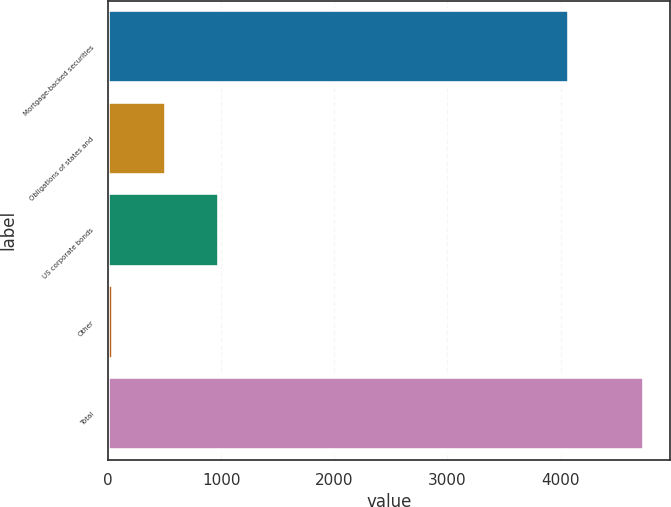Convert chart to OTSL. <chart><loc_0><loc_0><loc_500><loc_500><bar_chart><fcel>Mortgage-backed securities<fcel>Obligations of states and<fcel>US corporate bonds<fcel>Other<fcel>Total<nl><fcel>4071<fcel>510.3<fcel>979.6<fcel>41<fcel>4734<nl></chart> 